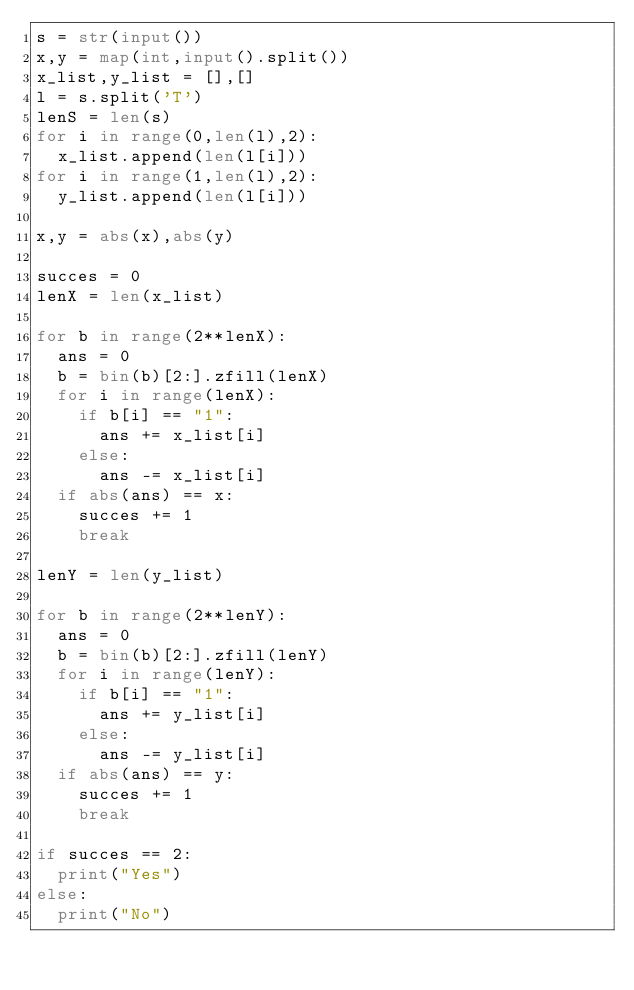Convert code to text. <code><loc_0><loc_0><loc_500><loc_500><_Python_>s = str(input())
x,y = map(int,input().split())
x_list,y_list = [],[]
l = s.split('T')
lenS = len(s)
for i in range(0,len(l),2):
  x_list.append(len(l[i]))
for i in range(1,len(l),2):
  y_list.append(len(l[i]))

x,y = abs(x),abs(y)

succes = 0
lenX = len(x_list)

for b in range(2**lenX):
  ans = 0
  b = bin(b)[2:].zfill(lenX)
  for i in range(lenX):
    if b[i] == "1":
      ans += x_list[i]
    else:
      ans -= x_list[i]
  if abs(ans) == x:
    succes += 1
    break

lenY = len(y_list)

for b in range(2**lenY):
  ans = 0
  b = bin(b)[2:].zfill(lenY)
  for i in range(lenY):
    if b[i] == "1":
      ans += y_list[i]
    else:
      ans -= y_list[i]
  if abs(ans) == y:
    succes += 1
    break

if succes == 2:
  print("Yes")
else:
  print("No")</code> 